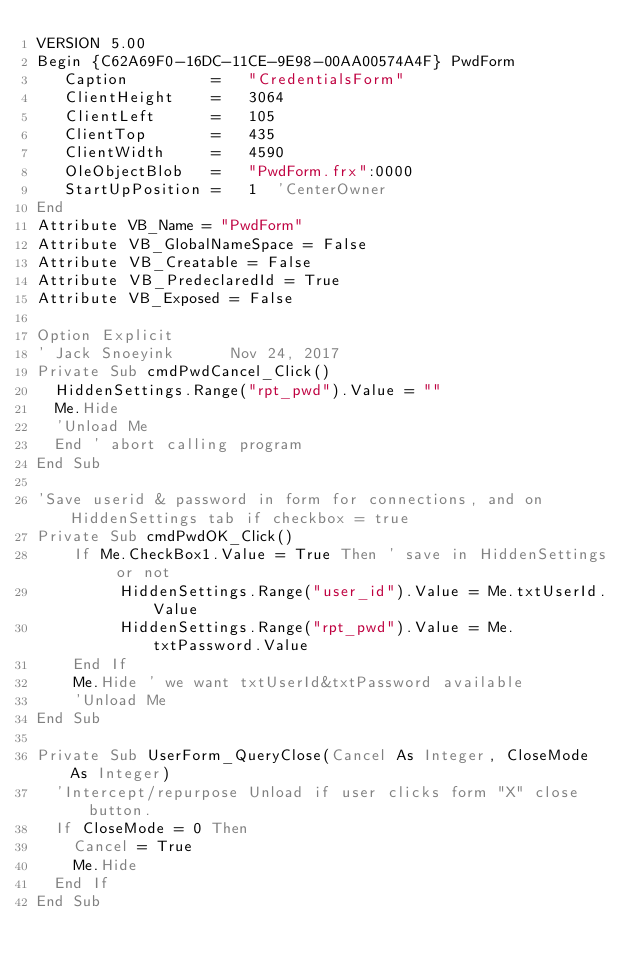<code> <loc_0><loc_0><loc_500><loc_500><_VisualBasic_>VERSION 5.00
Begin {C62A69F0-16DC-11CE-9E98-00AA00574A4F} PwdForm 
   Caption         =   "CredentialsForm"
   ClientHeight    =   3064
   ClientLeft      =   105
   ClientTop       =   435
   ClientWidth     =   4590
   OleObjectBlob   =   "PwdForm.frx":0000
   StartUpPosition =   1  'CenterOwner
End
Attribute VB_Name = "PwdForm"
Attribute VB_GlobalNameSpace = False
Attribute VB_Creatable = False
Attribute VB_PredeclaredId = True
Attribute VB_Exposed = False

Option Explicit
' Jack Snoeyink      Nov 24, 2017
Private Sub cmdPwdCancel_Click()
  HiddenSettings.Range("rpt_pwd").Value = ""
  Me.Hide
  'Unload Me
  End ' abort calling program
End Sub

'Save userid & password in form for connections, and on HiddenSettings tab if checkbox = true
Private Sub cmdPwdOK_Click()
    If Me.CheckBox1.Value = True Then ' save in HiddenSettings or not
         HiddenSettings.Range("user_id").Value = Me.txtUserId.Value
         HiddenSettings.Range("rpt_pwd").Value = Me.txtPassword.Value
    End If
    Me.Hide ' we want txtUserId&txtPassword available
    'Unload Me
End Sub

Private Sub UserForm_QueryClose(Cancel As Integer, CloseMode As Integer)
  'Intercept/repurpose Unload if user clicks form "X" close button.
  If CloseMode = 0 Then
    Cancel = True
    Me.Hide
  End If
End Sub
</code> 